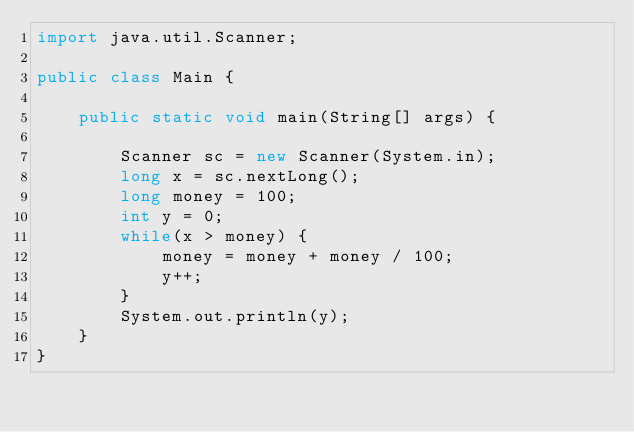Convert code to text. <code><loc_0><loc_0><loc_500><loc_500><_Java_>import java.util.Scanner;
 
public class Main {
 
	public static void main(String[] args) {
 
		Scanner sc = new Scanner(System.in);
		long x = sc.nextLong();
		long money = 100;
		int y = 0;
		while(x > money) {
			money = money + money / 100;
			y++;
		}
		System.out.println(y);
	}
}</code> 